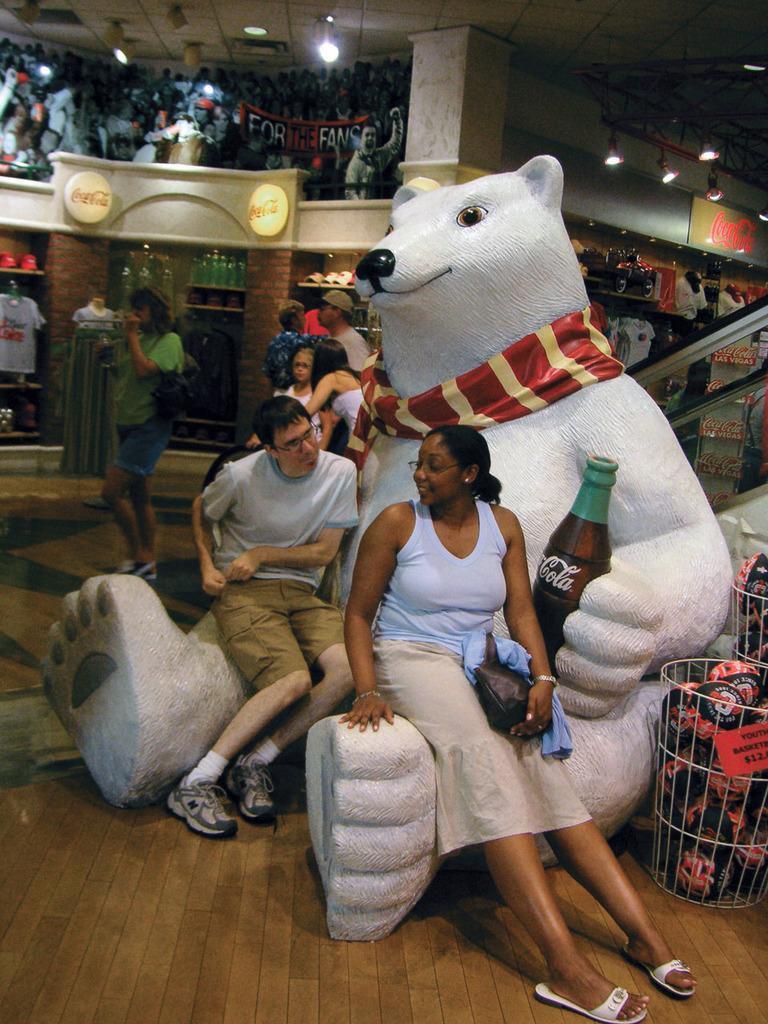Could you give a brief overview of what you see in this image? In this image we can see two persons are sitting on a bear doll and it is holding a cool drink bottle in the hand. On the right side there are objects on the floor. In the background we can see few persons, lights on the ceiling and poles, wall and other objects. 